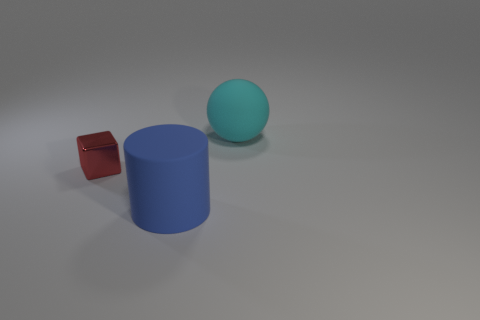Subtract all green balls. Subtract all purple cubes. How many balls are left? 1 Add 1 rubber spheres. How many objects exist? 4 Subtract all balls. How many objects are left? 2 Subtract all big cyan rubber balls. Subtract all large cyan matte balls. How many objects are left? 1 Add 3 small red things. How many small red things are left? 4 Add 3 red metal things. How many red metal things exist? 4 Subtract 1 red blocks. How many objects are left? 2 